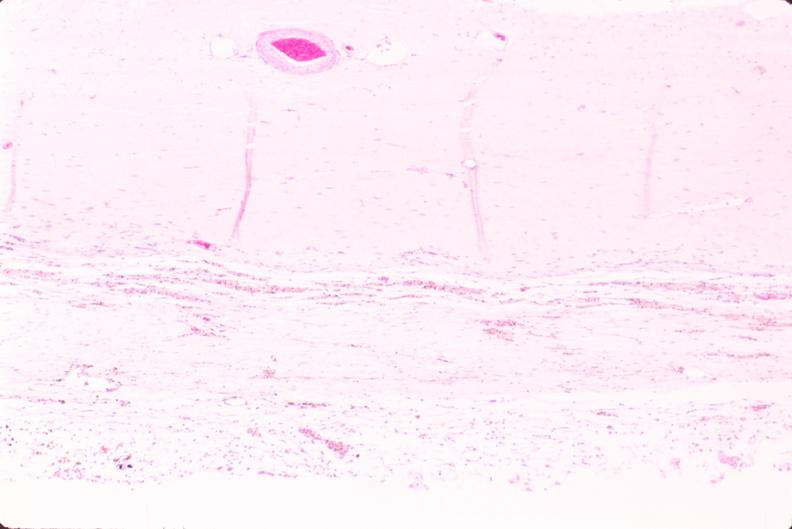what is present?
Answer the question using a single word or phrase. Nervous 